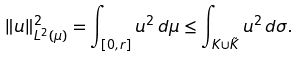Convert formula to latex. <formula><loc_0><loc_0><loc_500><loc_500>\| u \| _ { L ^ { 2 } ( \mu ) } ^ { 2 } = \int _ { [ 0 , r ] } u ^ { 2 } \, d \mu \leq \int _ { K \cup \tilde { K } } u ^ { 2 } \, d \sigma .</formula> 